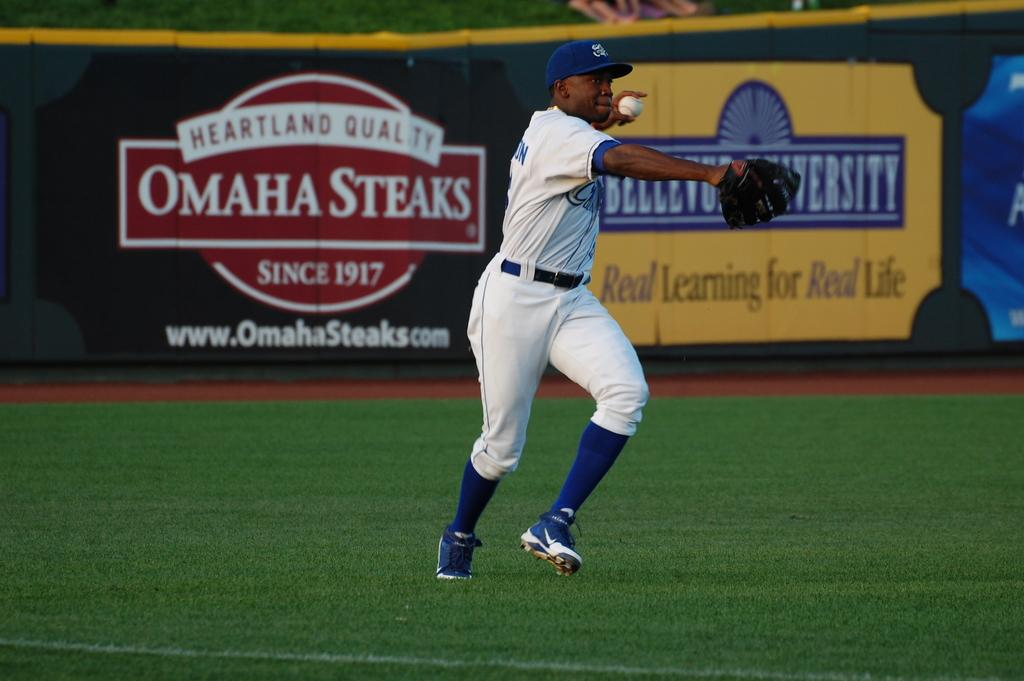<image>
Describe the image concisely. A baseball player on a field sponsored by Omaha Steaks. 